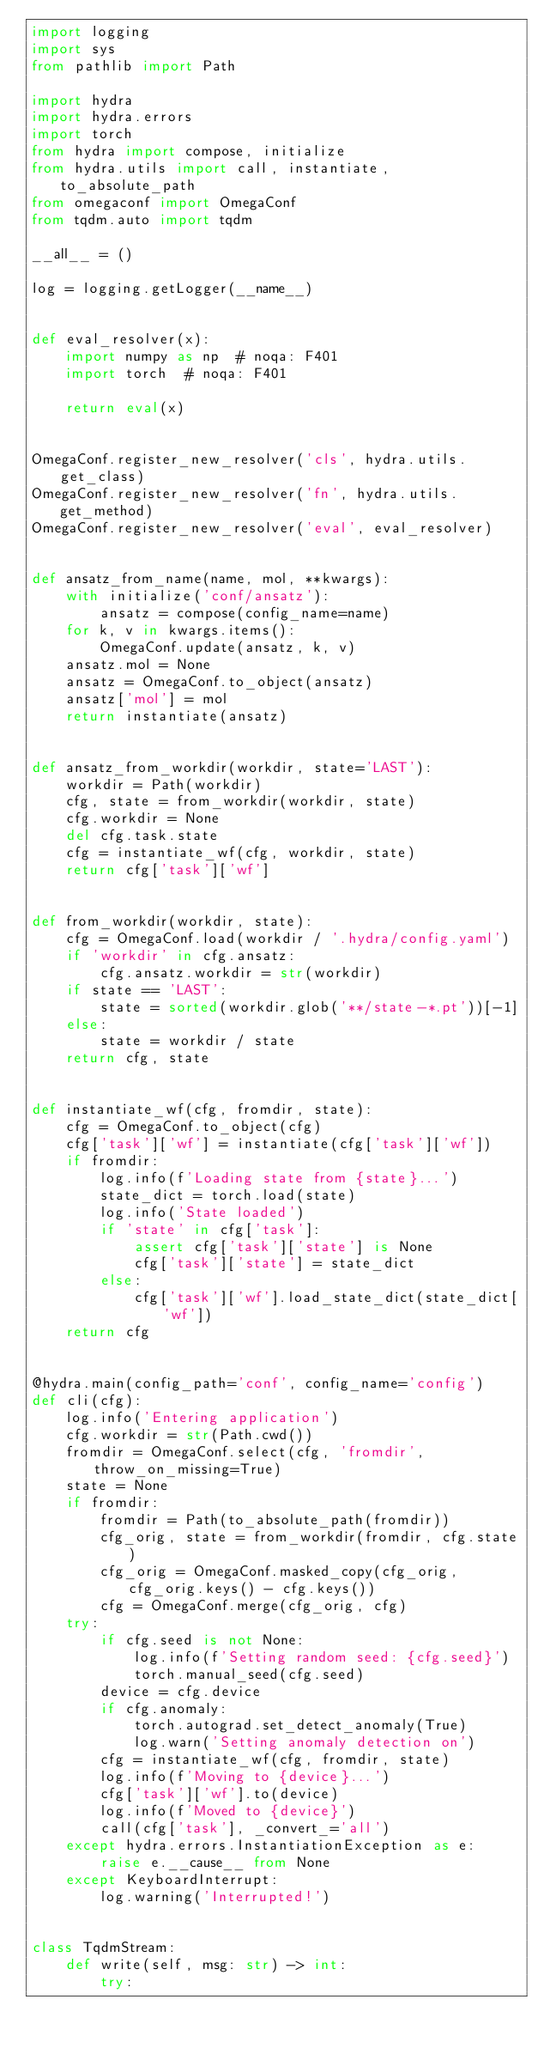Convert code to text. <code><loc_0><loc_0><loc_500><loc_500><_Python_>import logging
import sys
from pathlib import Path

import hydra
import hydra.errors
import torch
from hydra import compose, initialize
from hydra.utils import call, instantiate, to_absolute_path
from omegaconf import OmegaConf
from tqdm.auto import tqdm

__all__ = ()

log = logging.getLogger(__name__)


def eval_resolver(x):
    import numpy as np  # noqa: F401
    import torch  # noqa: F401

    return eval(x)


OmegaConf.register_new_resolver('cls', hydra.utils.get_class)
OmegaConf.register_new_resolver('fn', hydra.utils.get_method)
OmegaConf.register_new_resolver('eval', eval_resolver)


def ansatz_from_name(name, mol, **kwargs):
    with initialize('conf/ansatz'):
        ansatz = compose(config_name=name)
    for k, v in kwargs.items():
        OmegaConf.update(ansatz, k, v)
    ansatz.mol = None
    ansatz = OmegaConf.to_object(ansatz)
    ansatz['mol'] = mol
    return instantiate(ansatz)


def ansatz_from_workdir(workdir, state='LAST'):
    workdir = Path(workdir)
    cfg, state = from_workdir(workdir, state)
    cfg.workdir = None
    del cfg.task.state
    cfg = instantiate_wf(cfg, workdir, state)
    return cfg['task']['wf']


def from_workdir(workdir, state):
    cfg = OmegaConf.load(workdir / '.hydra/config.yaml')
    if 'workdir' in cfg.ansatz:
        cfg.ansatz.workdir = str(workdir)
    if state == 'LAST':
        state = sorted(workdir.glob('**/state-*.pt'))[-1]
    else:
        state = workdir / state
    return cfg, state


def instantiate_wf(cfg, fromdir, state):
    cfg = OmegaConf.to_object(cfg)
    cfg['task']['wf'] = instantiate(cfg['task']['wf'])
    if fromdir:
        log.info(f'Loading state from {state}...')
        state_dict = torch.load(state)
        log.info('State loaded')
        if 'state' in cfg['task']:
            assert cfg['task']['state'] is None
            cfg['task']['state'] = state_dict
        else:
            cfg['task']['wf'].load_state_dict(state_dict['wf'])
    return cfg


@hydra.main(config_path='conf', config_name='config')
def cli(cfg):
    log.info('Entering application')
    cfg.workdir = str(Path.cwd())
    fromdir = OmegaConf.select(cfg, 'fromdir', throw_on_missing=True)
    state = None
    if fromdir:
        fromdir = Path(to_absolute_path(fromdir))
        cfg_orig, state = from_workdir(fromdir, cfg.state)
        cfg_orig = OmegaConf.masked_copy(cfg_orig, cfg_orig.keys() - cfg.keys())
        cfg = OmegaConf.merge(cfg_orig, cfg)
    try:
        if cfg.seed is not None:
            log.info(f'Setting random seed: {cfg.seed}')
            torch.manual_seed(cfg.seed)
        device = cfg.device
        if cfg.anomaly:
            torch.autograd.set_detect_anomaly(True)
            log.warn('Setting anomaly detection on')
        cfg = instantiate_wf(cfg, fromdir, state)
        log.info(f'Moving to {device}...')
        cfg['task']['wf'].to(device)
        log.info(f'Moved to {device}')
        call(cfg['task'], _convert_='all')
    except hydra.errors.InstantiationException as e:
        raise e.__cause__ from None
    except KeyboardInterrupt:
        log.warning('Interrupted!')


class TqdmStream:
    def write(self, msg: str) -> int:
        try:</code> 